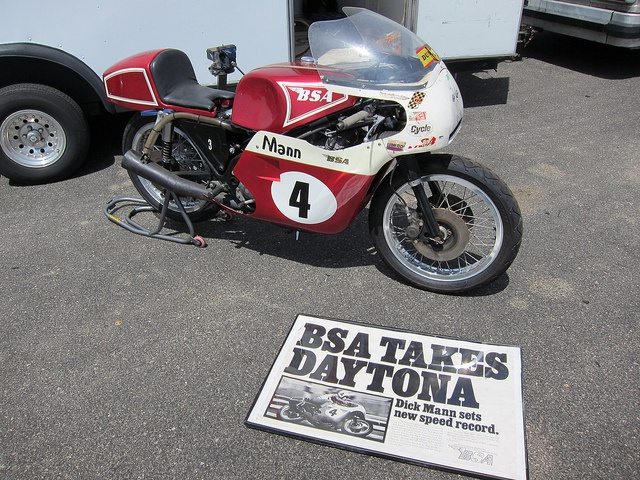Describe the objects in this image and their specific colors. I can see motorcycle in lightgray, black, gray, and darkgray tones, truck in lightgray, black, and gray tones, and car in lightgray, black, gray, and darkgray tones in this image. 